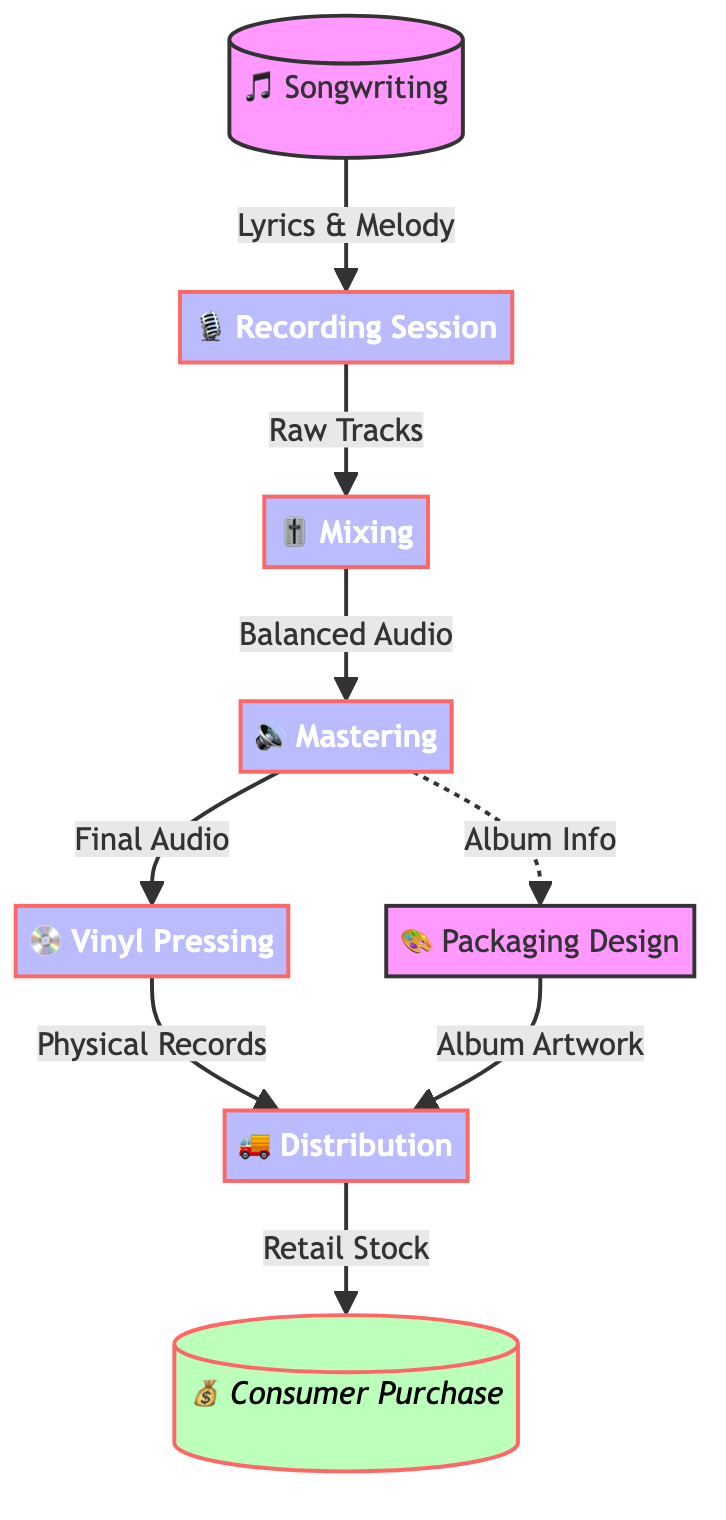What is the first step in the journey of a vinyl record? The flowchart indicates that the journey begins with "Songwriting," where the creation of lyrics and melody occurs.
Answer: Songwriting How many nodes are in the flowchart? By counting the distinct steps or phases represented in the flowchart, we identify a total of eight nodes: Songwriting, Recording Session, Mixing, Mastering, Vinyl Pressing, Packaging Design, Distribution, and Consumer Purchase.
Answer: Eight What is the output of the Mixing stage? According to the flowchart, the output from the Mixing stage is "Balanced Audio," which signifies the processed audio tracks ready for the next stage.
Answer: Balanced Audio Which two steps lead to the Distribution phase? The flowchart shows that two inputs lead to the Distribution phase: "Physical Records" from Vinyl Pressing and "Album Artwork" from Packaging Design.
Answer: Physical Records and Album Artwork What does the last step in the flowchart represent? The last step in the flowchart represents "Consumer Purchase," highlighting the end of the production journey where consumers acquire the vinyl records.
Answer: Consumer Purchase What type of node is the Packaging Design? The flowchart classifies "Packaging Design" under the default category, indicating it is not a primary process like the others but plays an essential supporting role in the journey.
Answer: Default How are the outputs of the Mastering stage utilized according to the diagram? The output from the Mastering stage, "Final Audio," is used for the Vinyl Pressing process, while "Album Info" is directed to Packaging Design, indicating its dual usage for both physical record creation and artwork design.
Answer: Final Audio and Album Info What is the relationship between Mastering and Vinyl Pressing? The flowchart shows a direct relationship where the "Final Audio" produced during the Mastering process is an essential input for creating the vinyl records during the Vinyl Pressing stage.
Answer: Final Audio 